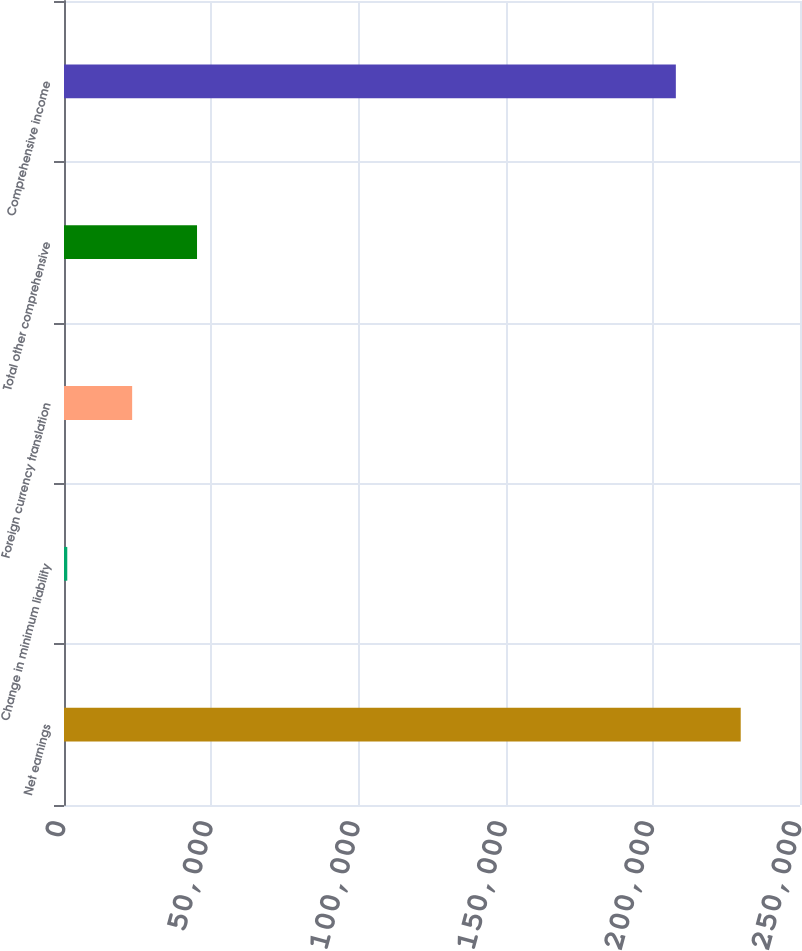<chart> <loc_0><loc_0><loc_500><loc_500><bar_chart><fcel>Net earnings<fcel>Change in minimum liability<fcel>Foreign currency translation<fcel>Total other comprehensive<fcel>Comprehensive income<nl><fcel>229864<fcel>1113<fcel>23149.1<fcel>45185.2<fcel>207828<nl></chart> 